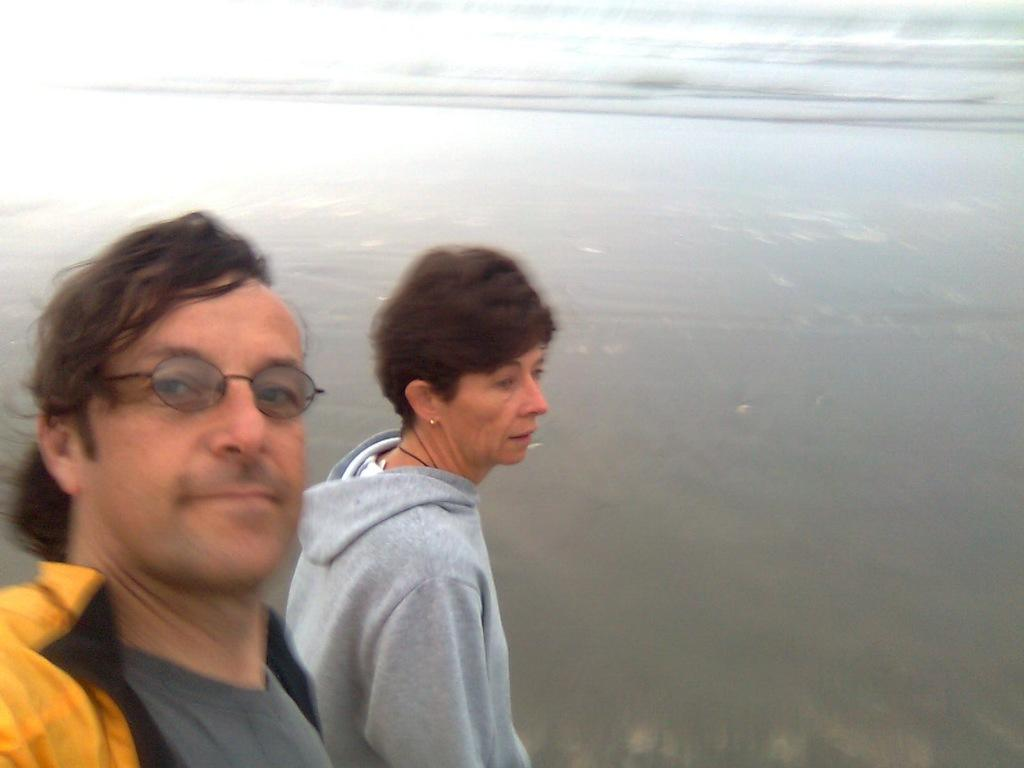Who are the people in the image? There is a man and a lady in the image. What can be seen in the background of the image? Water is visible in the background of the image. What type of glass is the lady holding in the image? There is no glass present in the image. What color is the gold jewelry worn by the man in the image? There is no gold jewelry or any jewelry mentioned in the image. 